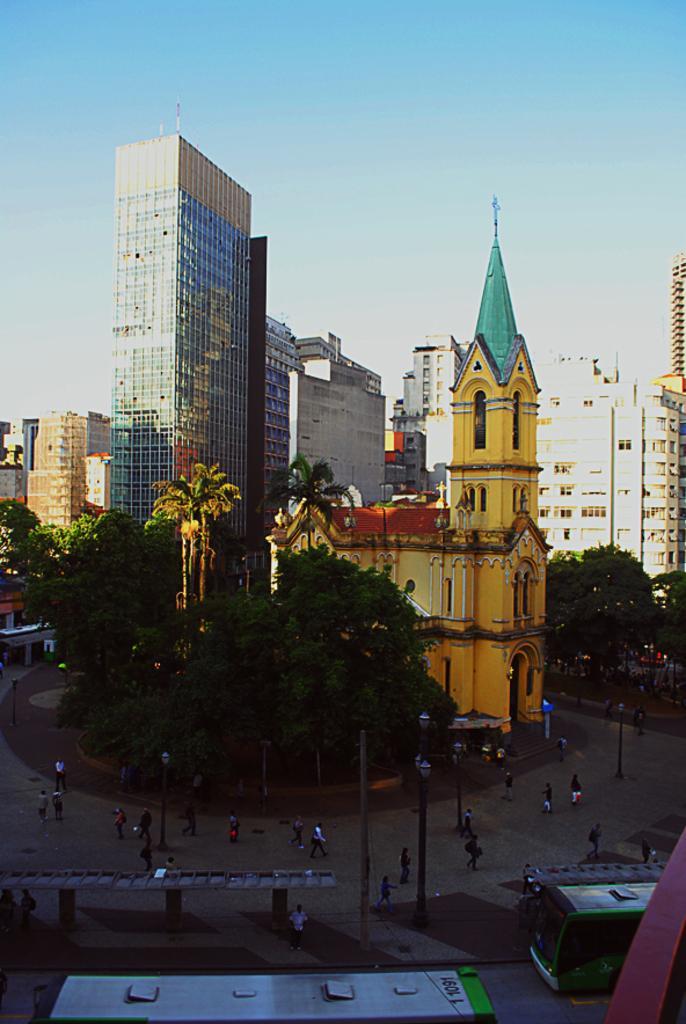Please provide a concise description of this image. In this picture we can see there are trees, buildings, people and a bus stop. There are poles with lights. At the bottom of the image there are two vehicles on the road. Behind the buildings there is the sky. 